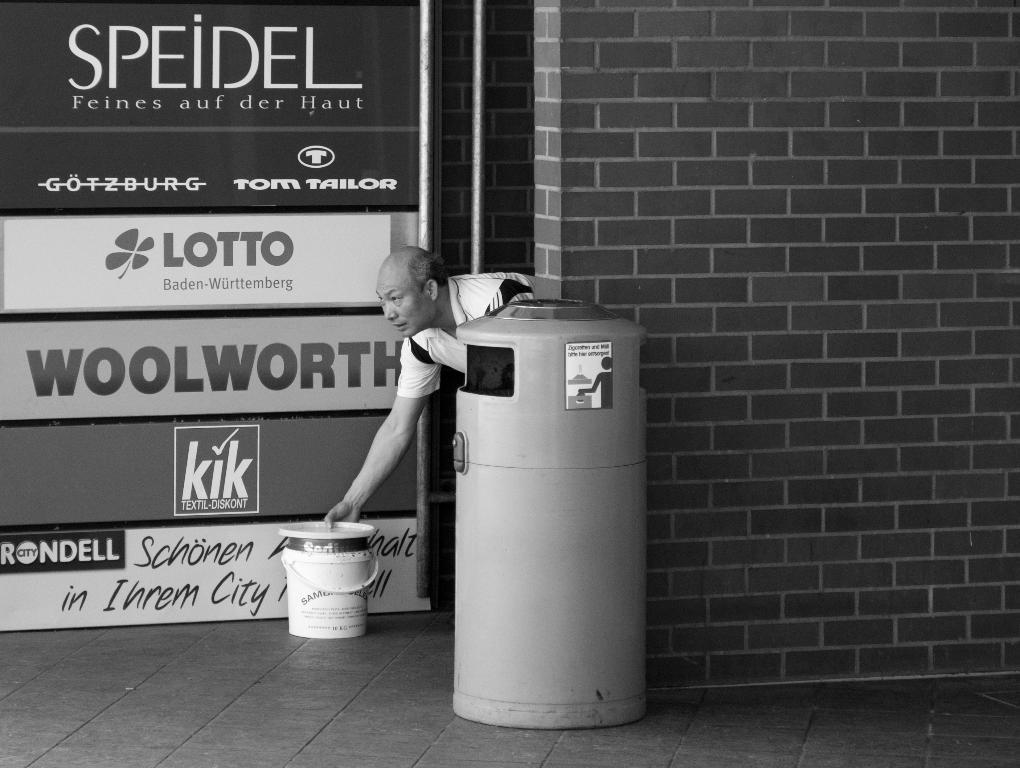<image>
Write a terse but informative summary of the picture. A black and white photo of a man, a litter bin and an advert for Lotto. 